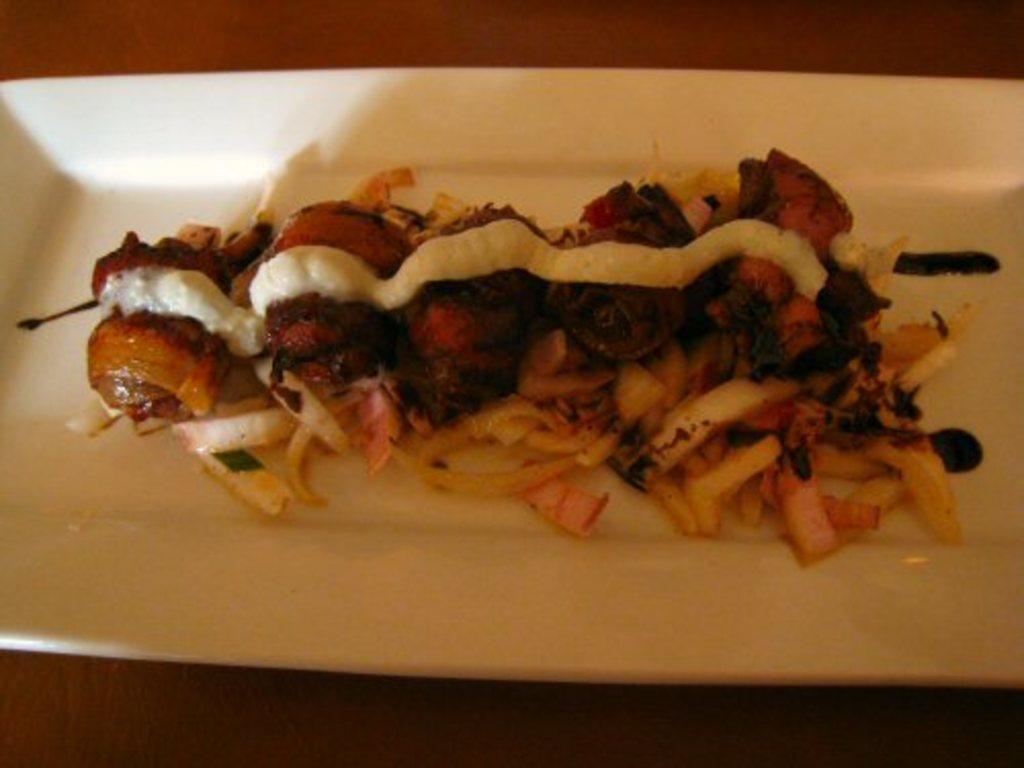What object is present on the table in the image? There is a plate on the table in the image. What is the purpose of the plate? The plate is used to hold food. Can you describe the food on the plate? Unfortunately, the specific type of food on the plate cannot be determined from the provided facts. How many beds are visible in the image? There are no beds present in the image; it only features a plate on a table. 